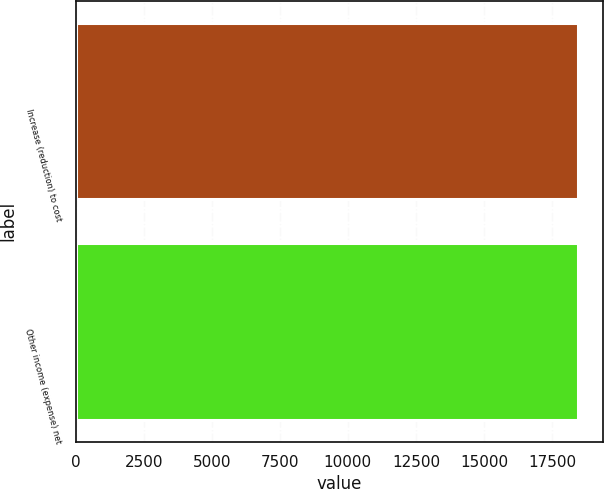<chart> <loc_0><loc_0><loc_500><loc_500><bar_chart><fcel>Increase (reduction) to cost<fcel>Other income (expense) net<nl><fcel>18453<fcel>18453.1<nl></chart> 